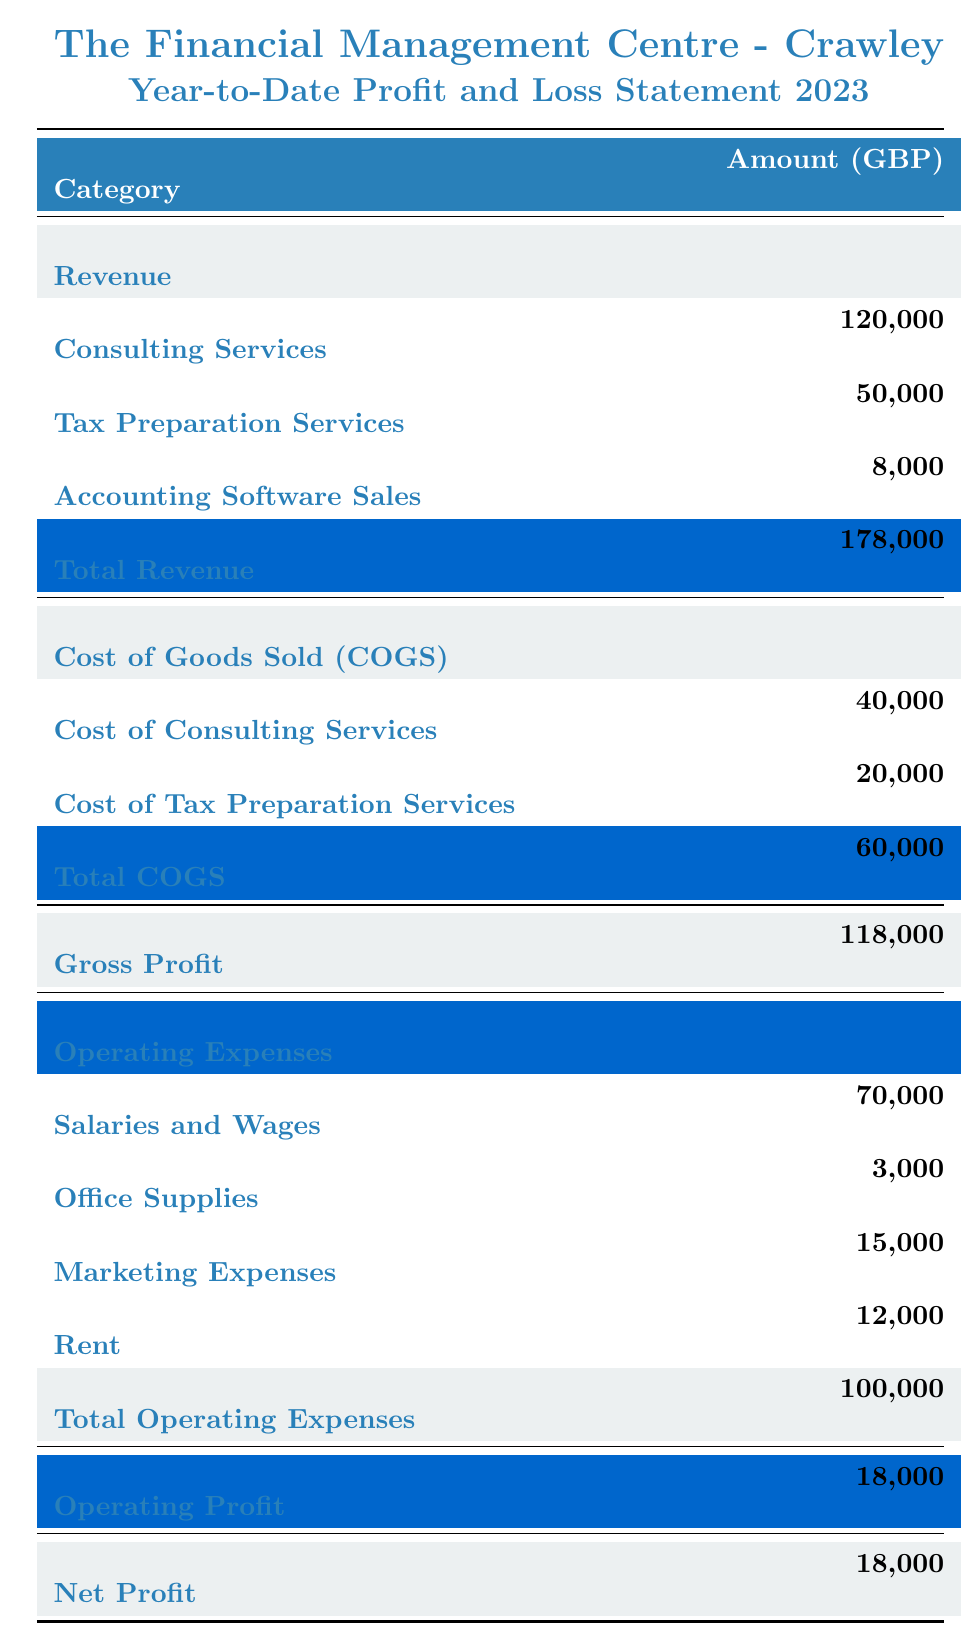What is the total revenue for the firm? The total revenue can be found at the bottom of the revenue section in the table. It is listed as 178,000 GBP.
Answer: 178,000 GBP How much is spent on salaries and wages? Salaries and wages are listed under operating expenses in the table, with an amount of 70,000 GBP.
Answer: 70,000 GBP What is the amount of net profit for the firm? The net profit is shown at the bottom of the table, which is 18,000 GBP.
Answer: 18,000 GBP What is the total operating expenses? The total operating expenses can be found at the bottom of that section, which amounts to 100,000 GBP.
Answer: 100,000 GBP What is the gross profit calculated from the available data? The gross profit is found in the summary section of the table as 118,000 GBP. It is calculated by subtracting total COGS (60,000 GBP) from total revenue (178,000 GBP): 178,000 - 60,000 = 118,000.
Answer: 118,000 GBP Is the profit from accounting software sales higher than the cost of goods sold for tax preparation services? The profit from accounting software sales is 8,000 GBP, and the cost of goods sold for tax preparation services is 20,000 GBP. Since 8,000 is less than 20,000, the statement is false.
Answer: No What percentage of the total revenue is the operating profit? The operating profit is 18,000 GBP, and the total revenue is 178,000 GBP. To find the percentage: (18,000 / 178,000) * 100 = approximately 10.11%.
Answer: 10.11% If we combine the amounts from consulting services and tax preparation services, how much revenue do we get? The revenue from consulting services is 120,000 GBP, and from tax preparation services is 50,000 GBP, so combined: 120,000 + 50,000 = 170,000 GBP.
Answer: 170,000 GBP What is the difference between total revenue and total operating expenses? Total revenue is 178,000 GBP and total operating expenses are 100,000 GBP. The difference is calculated by: 178,000 - 100,000 = 78,000.
Answer: 78,000 GBP How much did the firm spend on office supplies compared to marketing expenses? The firm spent 3,000 GBP on office supplies and 15,000 GBP on marketing expenses. To compare: 3,000 is less than 15,000, indicating that more was spent on marketing expenses.
Answer: More on marketing expenses 